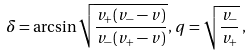Convert formula to latex. <formula><loc_0><loc_0><loc_500><loc_500>\delta = \arcsin \sqrt { \frac { v _ { + } ( v _ { - } - v ) } { v _ { - } ( v _ { + } - v ) } } , \, q = \sqrt { \frac { v _ { - } } { v _ { + } } } \, ,</formula> 